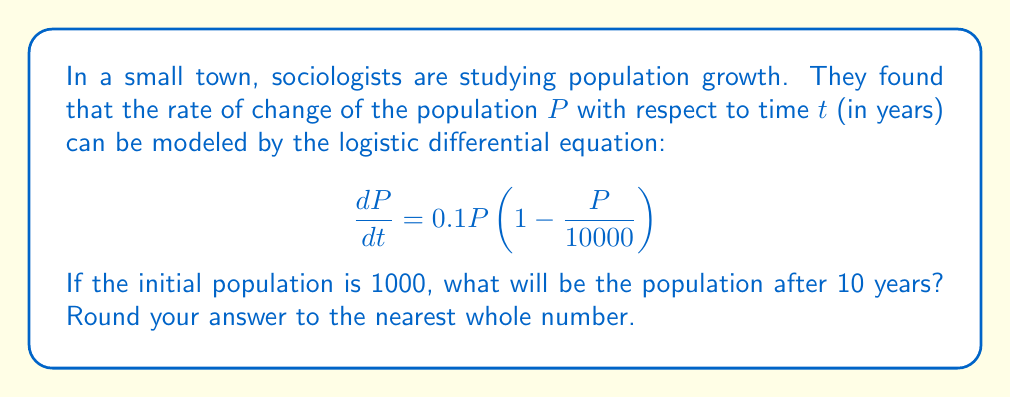Give your solution to this math problem. To solve this problem, we need to use the logistic growth model. Let's approach this step-by-step:

1) The logistic differential equation is given by:
   $$\frac{dP}{dt} = rP(1 - \frac{P}{K})$$
   where $r$ is the growth rate and $K$ is the carrying capacity.

2) In our case, $r = 0.1$ and $K = 10000$.

3) The solution to this differential equation is:
   $$P(t) = \frac{K}{1 + (\frac{K}{P_0} - 1)e^{-rt}}$$
   where $P_0$ is the initial population.

4) We're given that $P_0 = 1000$ and we need to find $P(10)$.

5) Plugging in all the values:
   $$P(10) = \frac{10000}{1 + (\frac{10000}{1000} - 1)e^{-0.1(10)}}$$

6) Simplify:
   $$P(10) = \frac{10000}{1 + 9e^{-1}}$$

7) Calculate:
   $$P(10) \approx 5052.61$$

8) Rounding to the nearest whole number:
   $$P(10) \approx 5053$$
Answer: 5053 